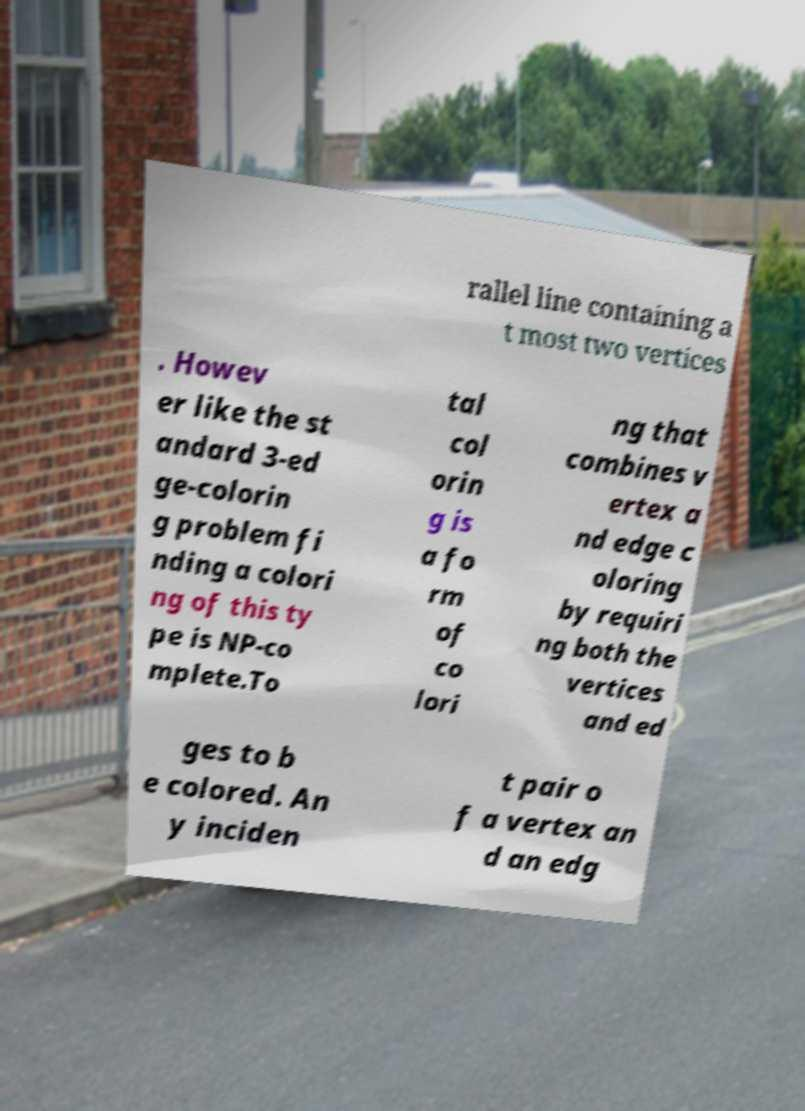Please identify and transcribe the text found in this image. rallel line containing a t most two vertices . Howev er like the st andard 3-ed ge-colorin g problem fi nding a colori ng of this ty pe is NP-co mplete.To tal col orin g is a fo rm of co lori ng that combines v ertex a nd edge c oloring by requiri ng both the vertices and ed ges to b e colored. An y inciden t pair o f a vertex an d an edg 